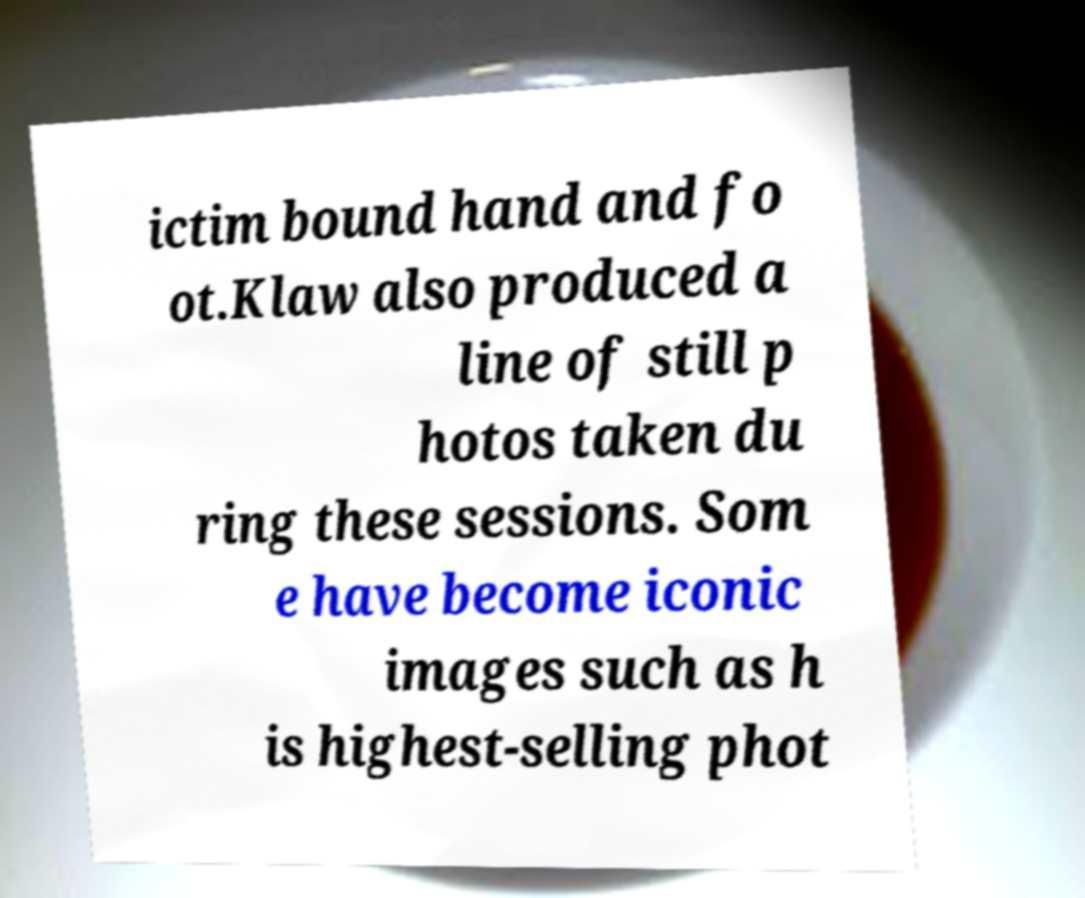Can you read and provide the text displayed in the image?This photo seems to have some interesting text. Can you extract and type it out for me? ictim bound hand and fo ot.Klaw also produced a line of still p hotos taken du ring these sessions. Som e have become iconic images such as h is highest-selling phot 